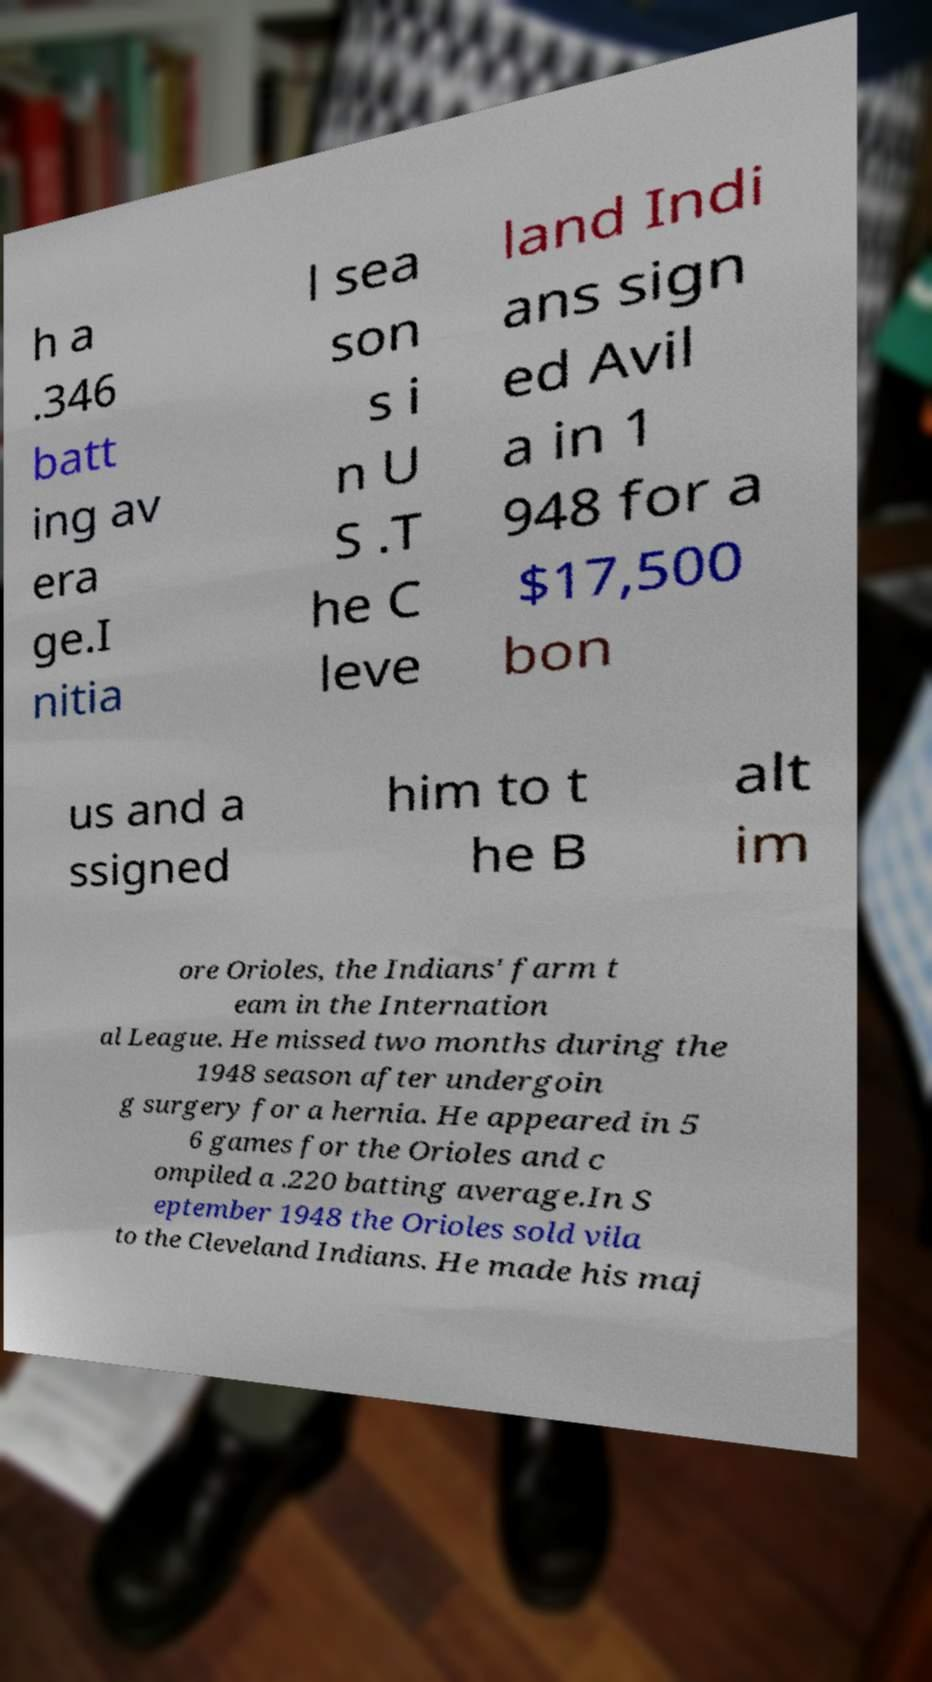Can you read and provide the text displayed in the image?This photo seems to have some interesting text. Can you extract and type it out for me? h a .346 batt ing av era ge.I nitia l sea son s i n U S .T he C leve land Indi ans sign ed Avil a in 1 948 for a $17,500 bon us and a ssigned him to t he B alt im ore Orioles, the Indians' farm t eam in the Internation al League. He missed two months during the 1948 season after undergoin g surgery for a hernia. He appeared in 5 6 games for the Orioles and c ompiled a .220 batting average.In S eptember 1948 the Orioles sold vila to the Cleveland Indians. He made his maj 